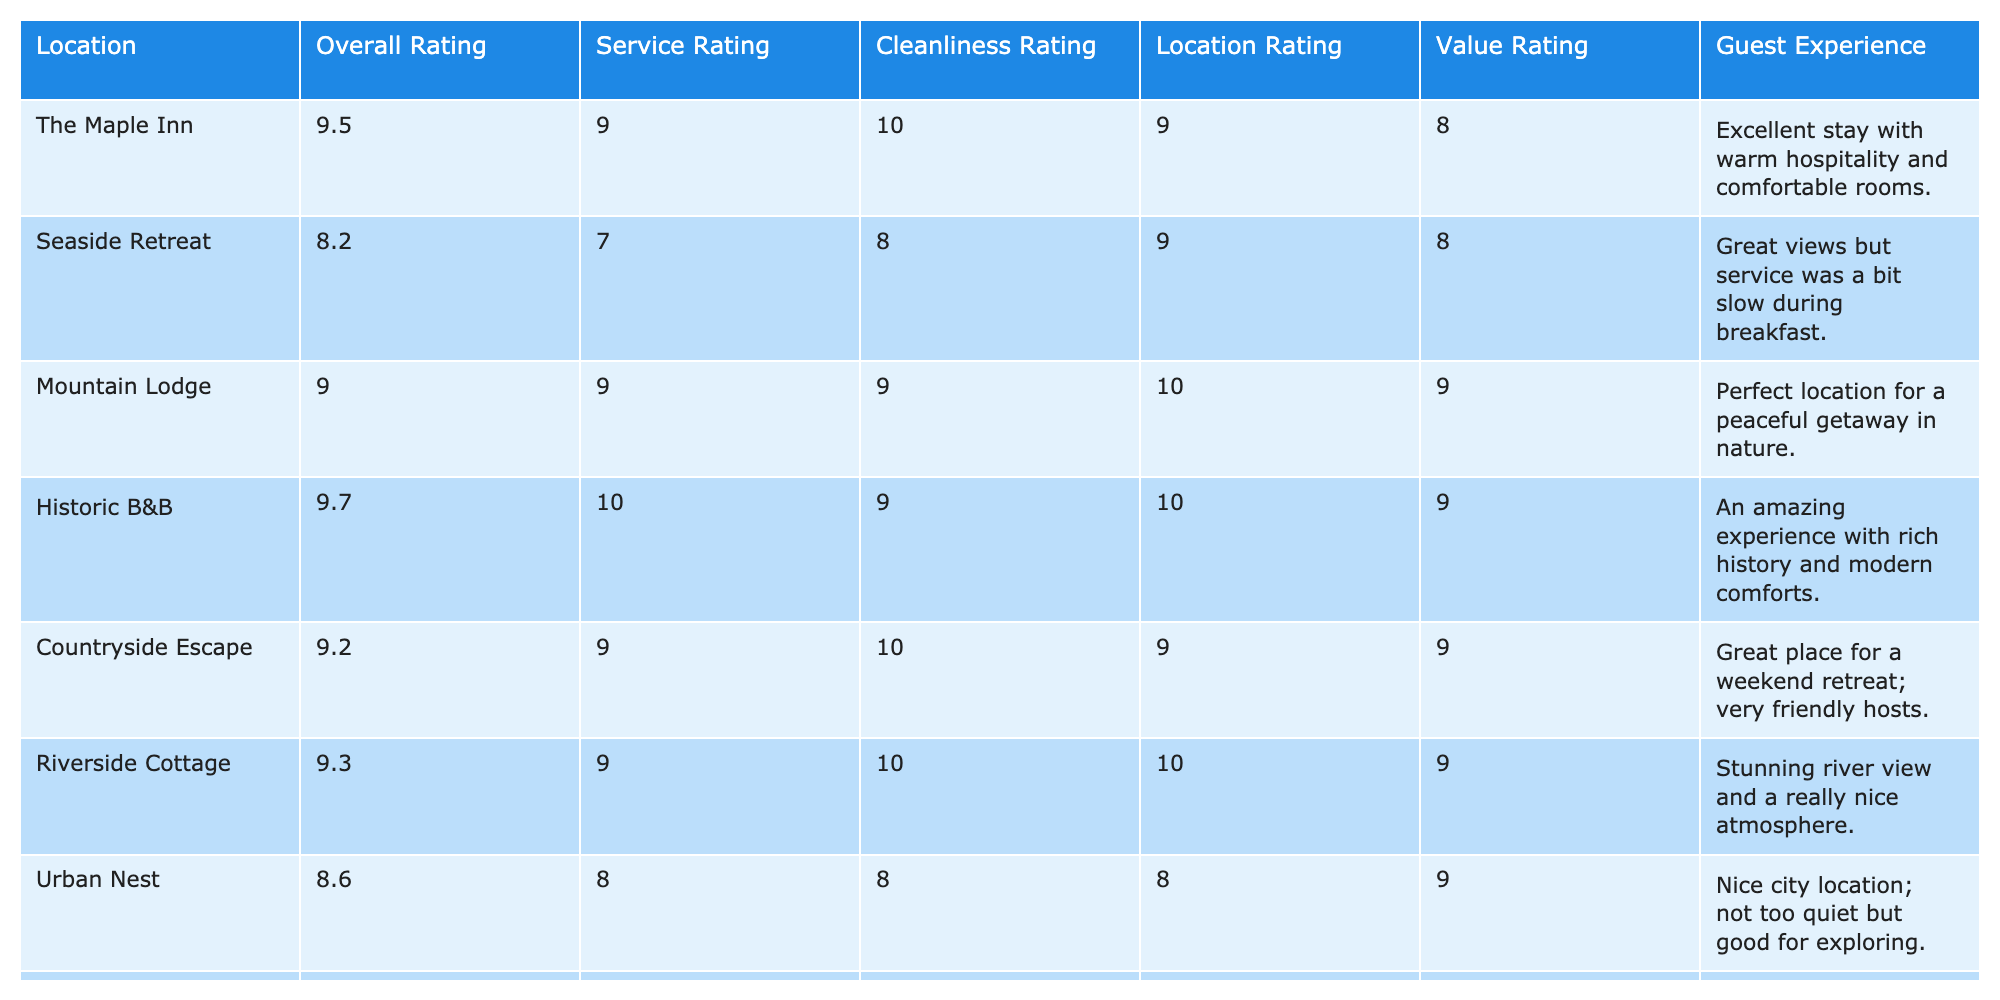What is the overall rating for the Historic B&B? The overall rating for the Historic B&B is listed in the table, and it shows a score of 9.7.
Answer: 9.7 Which bed and breakfast has the highest service rating? By examining the service ratings in the table, the Historic B&B has the highest service rating of 10.
Answer: Historic B&B What is the average cleanliness rating across all locations? To find the average cleanliness rating, add up all the cleanliness ratings (10 + 8 + 9 + 9 + 10 + 10 + 8 + 9 + 10 + 9 = 90) and divide by the number of locations (10). Thus, the average cleanliness rating is 90/10 = 9.0.
Answer: 9.0 Is the value rating of Urban Nest higher than that of Seaside Retreat? Urban Nest has a value rating of 9, while Seaside Retreat has a value rating of 8. Since 9 is greater than 8, the statement is true.
Answer: Yes Which locations have an overall rating of 9.5 or higher? Looking through the overall ratings, the locations with ratings of 9.5 or higher are The Maple Inn (9.5), Historic B&B (9.7), Pine Hill B&B (9.5), and Riverside Cottage (9.3). Thus, The Maple Inn, Historic B&B, and Pine Hill B&B meet this criterion.
Answer: The Maple Inn, Historic B&B, Pine Hill B&B What is the difference between the cleanliness rating of the best-rated B&B and the one with the lowest cleanliness rating? The best cleanliness rating is 10 (Pine Hill B&B, Riverside Cottage, and Countryside Escape all score 10), and the lowest rating is 7 (Urban Nest). The difference is 10 - 8 = 2.
Answer: 2 What is the guest experience comment for the Seaside Retreat? The guest experience column for the Seaside Retreat indicates, "Great views but service was a bit slow during breakfast."
Answer: Great views but service was a bit slow during breakfast Which location has the best overall rating, and what is its cleanliness rating? The best overall rating is for the Historic B&B which scores 9.7, and its cleanliness rating is 9.
Answer: Historic B&B, 9 What is the combined total of service ratings for all locations? Adding the service ratings together (9 + 7 + 9 + 10 + 9 + 9 + 8 + 10 + 8 + 9 = 89), the combined total of service ratings for all locations is 89.
Answer: 89 Does the Riverside Cottage have a higher location rating than the Urban Nest? Riverside Cottage has a location rating of 10 while Urban Nest has a location rating of 8. Since 10 is greater than 8, Riverside Cottage does have a higher rating.
Answer: Yes What is the average value rating of the bed and breakfasts that have a cleanliness rating of 10? The bed and breakfasts with a cleanliness rating of 10 are Pine Hill B&B, Riverside Cottage, and Countryside Escape. Their value ratings are 10, 9, and 9, respectively. The total is 10 + 9 + 9 = 28, and dividing by 3 (the number of B&Bs) gives an average of 28/3 ≈ 9.33.
Answer: 9.33 